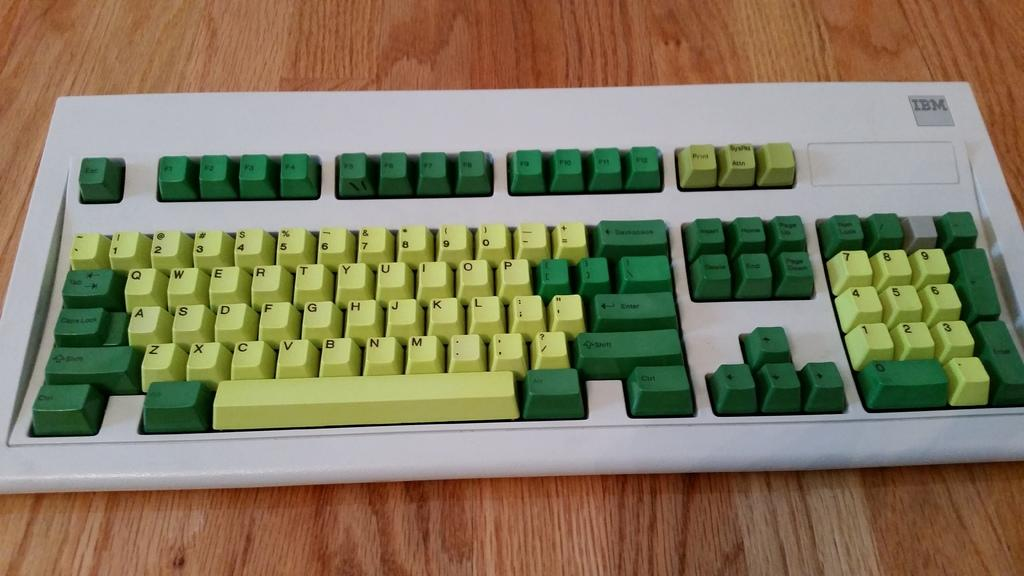<image>
Describe the image concisely. a keyboard has green keys and an IBM logo on it 